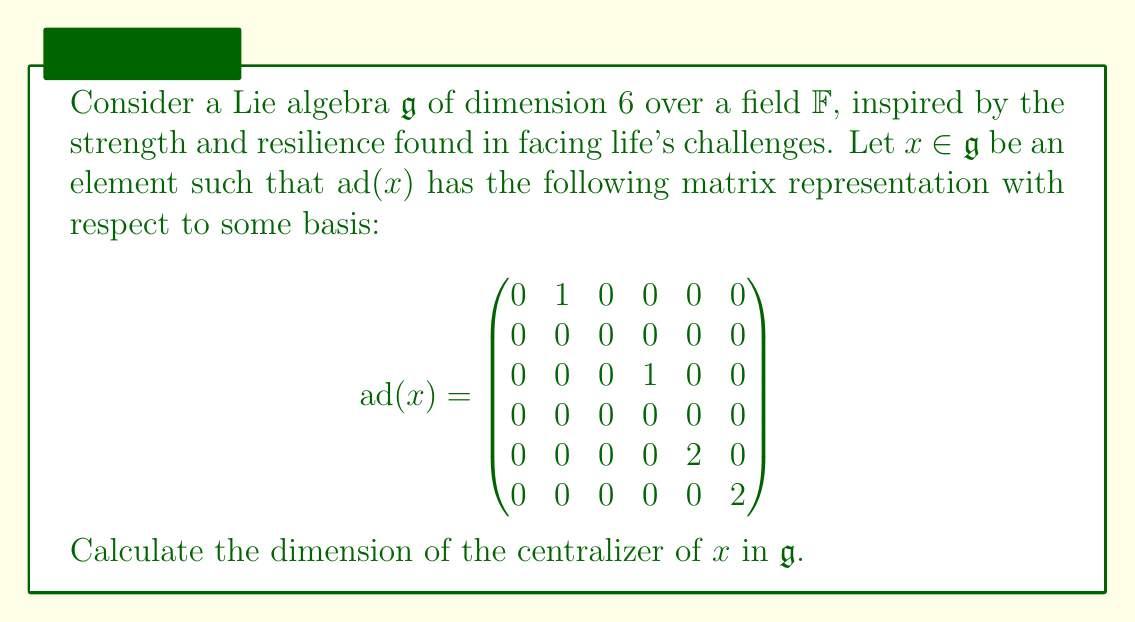Help me with this question. Let's approach this step-by-step:

1) The centralizer of $x$, denoted $C_{\mathfrak{g}}(x)$, is defined as:

   $C_{\mathfrak{g}}(x) = \{y \in \mathfrak{g} : [x,y] = 0\}$

2) In terms of the adjoint representation, this is equivalent to:

   $C_{\mathfrak{g}}(x) = \{y \in \mathfrak{g} : \text{ad}(x)(y) = 0\}$

3) This means we need to find the kernel of $\text{ad}(x)$. The dimension of the centralizer is equal to the dimension of this kernel.

4) To find the dimension of the kernel, we can use the rank-nullity theorem:

   $\dim(\ker(\text{ad}(x))) + \text{rank}(\text{ad}(x)) = \dim(\mathfrak{g}) = 6$

5) So, we need to find the rank of $\text{ad}(x)$. This is equal to the number of linearly independent columns (or rows) in the matrix.

6) Looking at the matrix, we can see that:
   - The first column has a non-zero entry in the second row
   - The third column has a non-zero entry in the fourth row
   - The fifth and sixth columns each have a non-zero entry in their respective rows

7) These four columns are linearly independent, so the rank of $\text{ad}(x)$ is 4.

8) Using the rank-nullity theorem:

   $\dim(\ker(\text{ad}(x))) + 4 = 6$
   $\dim(\ker(\text{ad}(x))) = 2$

Therefore, the dimension of the centralizer of $x$ is 2.
Answer: The dimension of the centralizer of $x$ in $\mathfrak{g}$ is 2. 